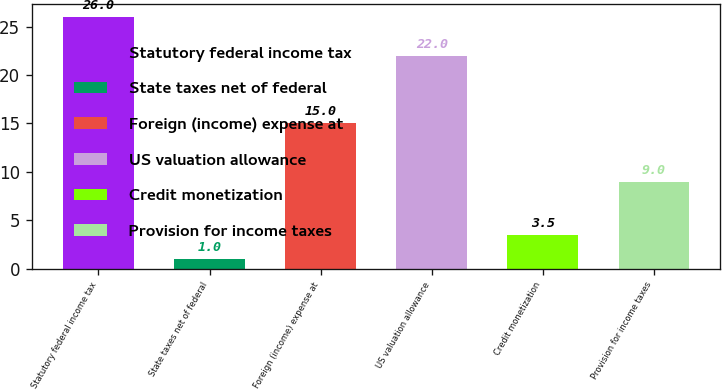<chart> <loc_0><loc_0><loc_500><loc_500><bar_chart><fcel>Statutory federal income tax<fcel>State taxes net of federal<fcel>Foreign (income) expense at<fcel>US valuation allowance<fcel>Credit monetization<fcel>Provision for income taxes<nl><fcel>26<fcel>1<fcel>15<fcel>22<fcel>3.5<fcel>9<nl></chart> 